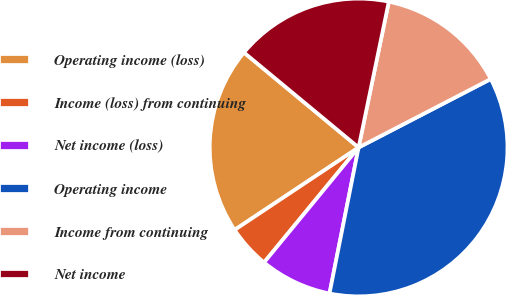Convert chart to OTSL. <chart><loc_0><loc_0><loc_500><loc_500><pie_chart><fcel>Operating income (loss)<fcel>Income (loss) from continuing<fcel>Net income (loss)<fcel>Operating income<fcel>Income from continuing<fcel>Net income<nl><fcel>20.35%<fcel>4.71%<fcel>7.82%<fcel>35.74%<fcel>14.14%<fcel>17.24%<nl></chart> 